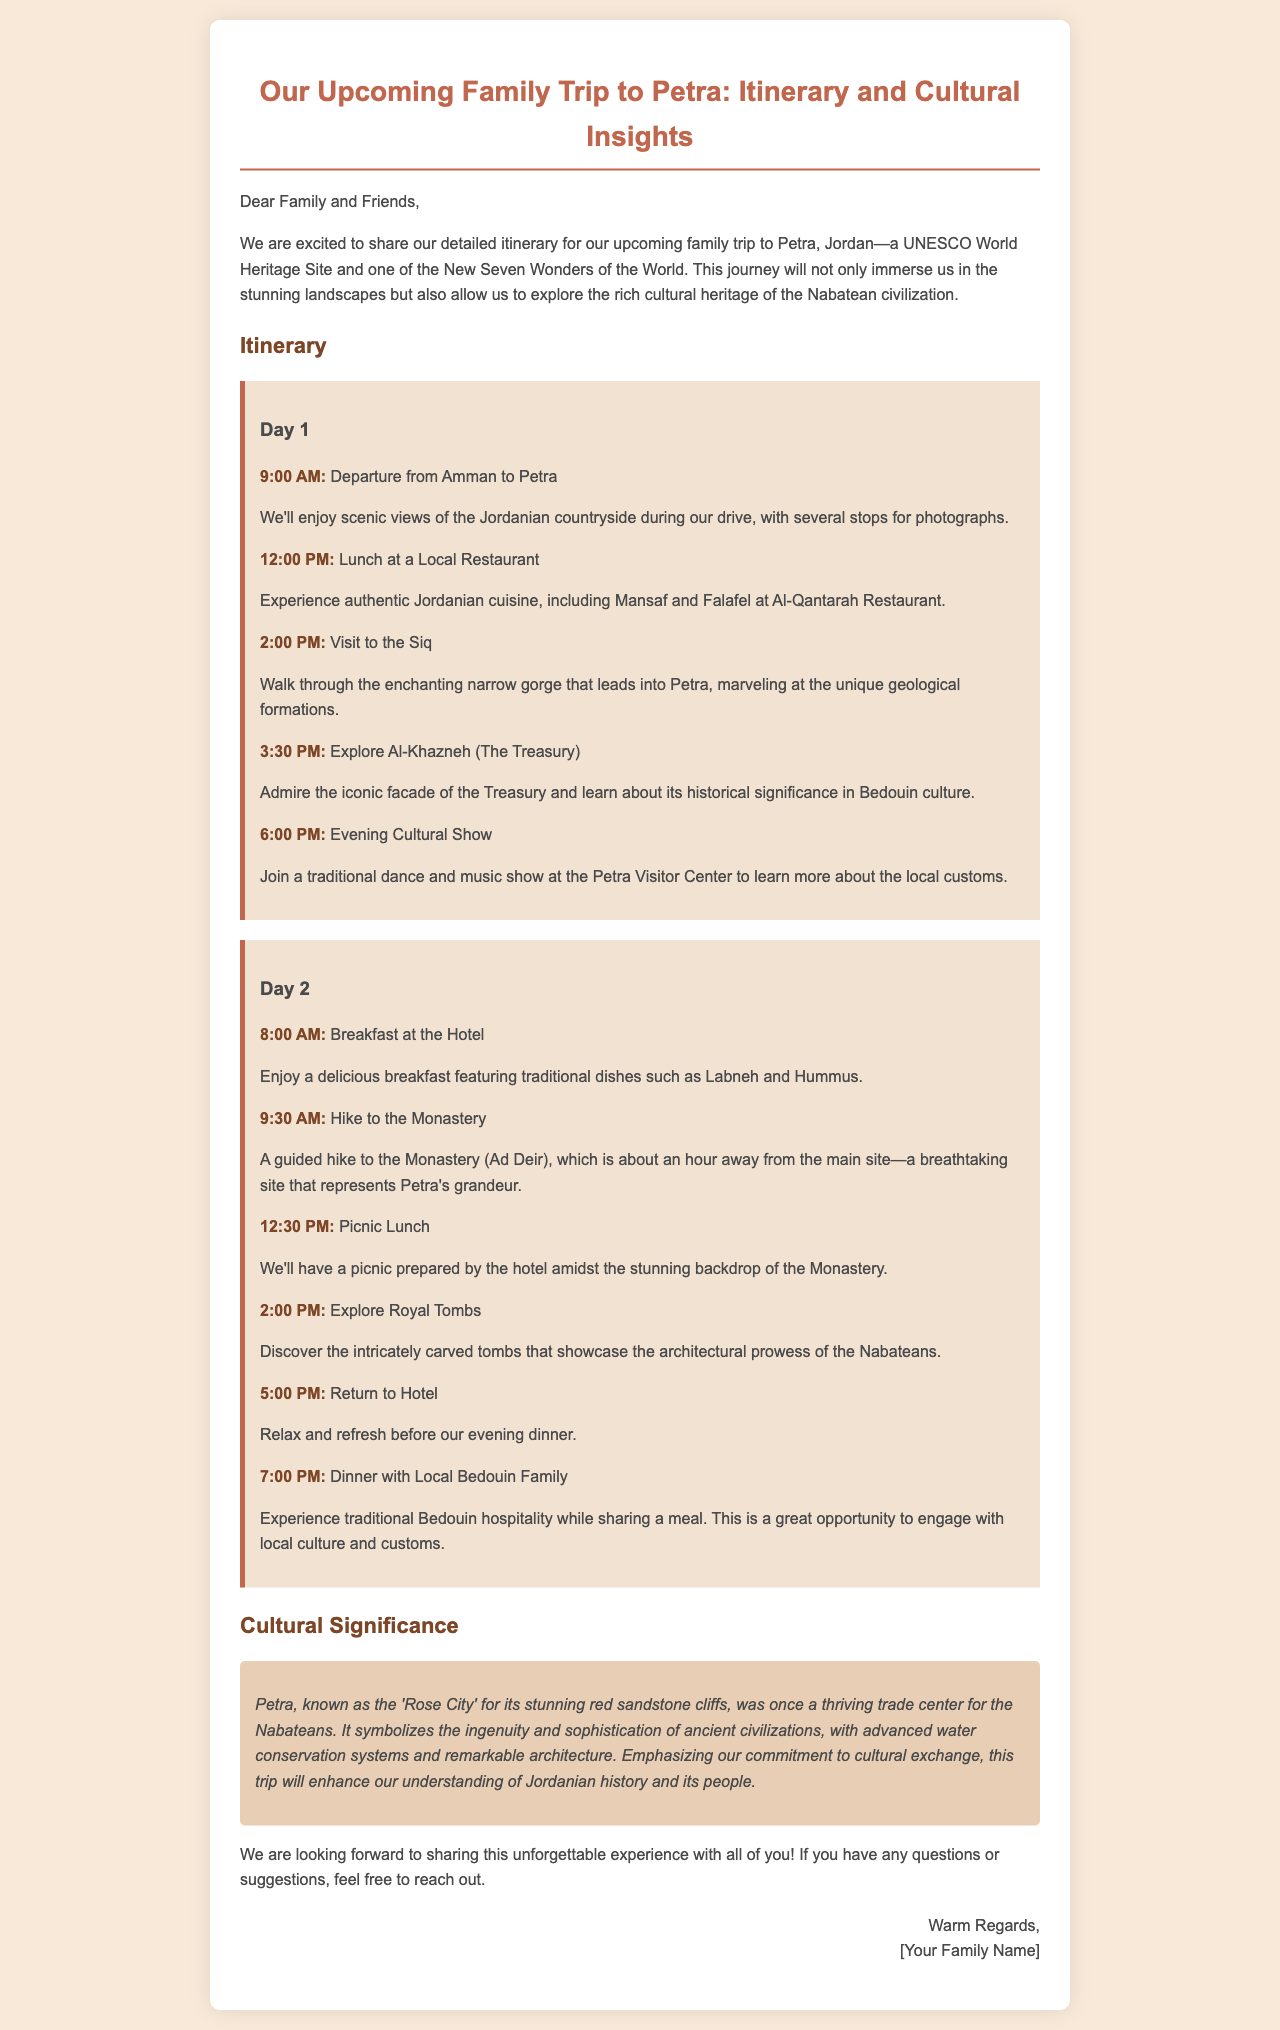What is the destination of the family trip? The family trip destination mentioned in the document is Petra, Jordan.
Answer: Petra, Jordan What is the cultural significance of Petra? The document states that Petra symbolizes the ingenuity and sophistication of ancient civilizations and was a thriving trade center for the Nabateans.
Answer: Ingenuity and sophistication of ancient civilizations What dish will be served for breakfast? The itinerary specifically mentions traditional dishes such as Labneh and Hummus served for breakfast at the hotel.
Answer: Labneh and Hummus What time is the lunch on Day 1? According to the itinerary, lunch on Day 1 is scheduled for 12:00 PM.
Answer: 12:00 PM How many days will the trip last? The itinerary outlines activities for a total of two days.
Answer: Two days What activity is planned at 6:00 PM on Day 1? The itinerary lists an evening cultural show as the planned activity at 6:00 PM on Day 1.
Answer: Evening Cultural Show What type of meal will be experienced with the Bedouin family? The document mentions that the family will share a meal to experience traditional Bedouin hospitality.
Answer: Traditional Bedouin hospitality What is the time for the hike to the Monastery on Day 2? The hike to the Monastery is scheduled for 9:30 AM on Day 2.
Answer: 9:30 AM What is the main activity during the Day 2 picnic lunch? The picnic lunch will be prepared by the hotel amidst the stunning backdrop of the Monastery.
Answer: Picnic prepared by the hotel 